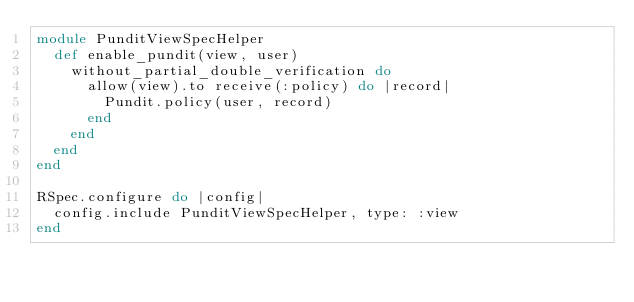Convert code to text. <code><loc_0><loc_0><loc_500><loc_500><_Ruby_>module PunditViewSpecHelper
  def enable_pundit(view, user)
    without_partial_double_verification do
      allow(view).to receive(:policy) do |record|
        Pundit.policy(user, record)
      end
    end
  end
end

RSpec.configure do |config|
  config.include PunditViewSpecHelper, type: :view
end
</code> 